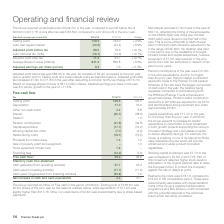According to Premier Foods Plc's financial document, What was the loss before tax reported in the year? According to the financial document, £(42.7)m. The relevant text states: "The Group reported a loss before tax of £(42.7)m in the year, compared to a profit before tax of £20.9m in 2017/18. A loss after tax was £(33.8)m, co..." Also, What was the adjusted profit before tax in the year? According to the financial document, £88.0m. The relevant text states: "Adjusted profit before tax was £88.0m in the year, an increase of £9.4m compared to the prior year due to growth both in Trading profit an..." Also, What was the increase in the adjusted profit after tax? According to the financial document, £7.6m. The relevant text states: "scribed above. Adjusted profit after tax increased £7.6m to £71.3m in the year after deducting a notional 19.0% tax charge of £16.7m. Based on average shares..." Also, can you calculate: What was the average trading profit for 2017/18 and 2018/19? To answer this question, I need to perform calculations using the financial data. The calculation is: (128.5 + 123.0) / 2, which equals 125.75 (in millions). This is based on the information: "share (£m) 2018/19 2017/18 Change Trading profit 128.5 123.0 +4.5% Less: Net regular interest (40.5) (44.4) +8.9% (£m) 2018/19 2017/18 Change Trading profit 128.5 123.0 +4.5% Less: Net regular interes..." The key data points involved are: 123.0, 128.5. Also, can you calculate: What is the change in the adjusted profit before tax from 2017/18 to 2018/19? Based on the calculation: 88.0 - 78.6, the result is 9.4 (in millions). This is based on the information: "Adjusted profit before tax 88.0 78.6 +12.1% Less: Notional tax (19%) (16.7) (14.9) (12.1%) Adjusted profit after tax 6 71.3 63.7 +1 Adjusted profit before tax 88.0 78.6 +12.1% Less: Notional tax (19%)..." The key data points involved are: 78.6, 88.0. Also, can you calculate: What is the average notional tax for 2017/18 and 2018/19? To answer this question, I need to perform calculations using the financial data. The calculation is: -(16.7 + 14.9) / 2, which equals -15.8 (in millions). This is based on the information: "88.0 78.6 +12.1% Less: Notional tax (19%) (16.7) (14.9) (12.1%) Adjusted profit after tax 6 71.3 63.7 +12.1% Average shares in issue (millions) 841.5 836. re tax 88.0 78.6 +12.1% Less: Notional tax (1..." The key data points involved are: 14.9, 16.7. 